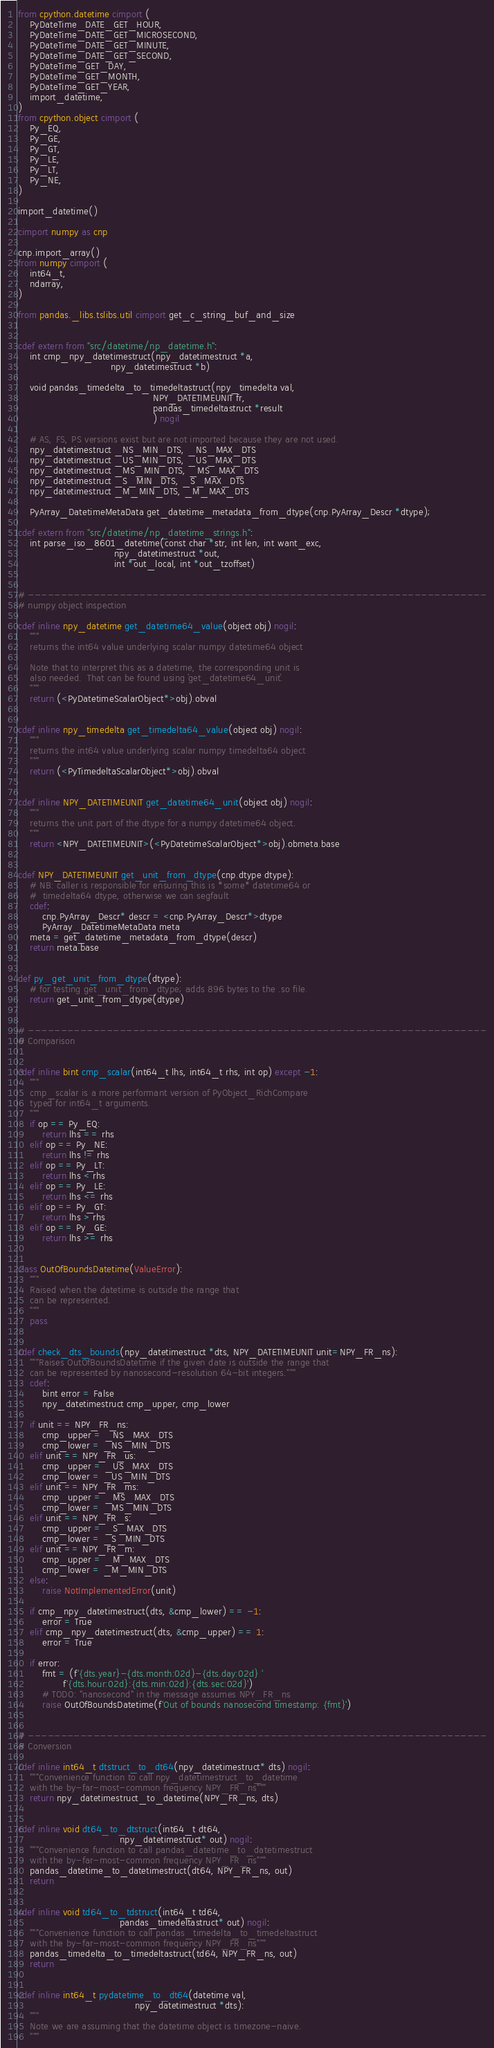Convert code to text. <code><loc_0><loc_0><loc_500><loc_500><_Cython_>from cpython.datetime cimport (
    PyDateTime_DATE_GET_HOUR,
    PyDateTime_DATE_GET_MICROSECOND,
    PyDateTime_DATE_GET_MINUTE,
    PyDateTime_DATE_GET_SECOND,
    PyDateTime_GET_DAY,
    PyDateTime_GET_MONTH,
    PyDateTime_GET_YEAR,
    import_datetime,
)
from cpython.object cimport (
    Py_EQ,
    Py_GE,
    Py_GT,
    Py_LE,
    Py_LT,
    Py_NE,
)

import_datetime()

cimport numpy as cnp

cnp.import_array()
from numpy cimport (
    int64_t,
    ndarray,
)

from pandas._libs.tslibs.util cimport get_c_string_buf_and_size


cdef extern from "src/datetime/np_datetime.h":
    int cmp_npy_datetimestruct(npy_datetimestruct *a,
                               npy_datetimestruct *b)

    void pandas_timedelta_to_timedeltastruct(npy_timedelta val,
                                             NPY_DATETIMEUNIT fr,
                                             pandas_timedeltastruct *result
                                             ) nogil

    # AS, FS, PS versions exist but are not imported because they are not used.
    npy_datetimestruct _NS_MIN_DTS, _NS_MAX_DTS
    npy_datetimestruct _US_MIN_DTS, _US_MAX_DTS
    npy_datetimestruct _MS_MIN_DTS, _MS_MAX_DTS
    npy_datetimestruct _S_MIN_DTS, _S_MAX_DTS
    npy_datetimestruct _M_MIN_DTS, _M_MAX_DTS

    PyArray_DatetimeMetaData get_datetime_metadata_from_dtype(cnp.PyArray_Descr *dtype);

cdef extern from "src/datetime/np_datetime_strings.h":
    int parse_iso_8601_datetime(const char *str, int len, int want_exc,
                                npy_datetimestruct *out,
                                int *out_local, int *out_tzoffset)


# ----------------------------------------------------------------------
# numpy object inspection

cdef inline npy_datetime get_datetime64_value(object obj) nogil:
    """
    returns the int64 value underlying scalar numpy datetime64 object

    Note that to interpret this as a datetime, the corresponding unit is
    also needed.  That can be found using `get_datetime64_unit`.
    """
    return (<PyDatetimeScalarObject*>obj).obval


cdef inline npy_timedelta get_timedelta64_value(object obj) nogil:
    """
    returns the int64 value underlying scalar numpy timedelta64 object
    """
    return (<PyTimedeltaScalarObject*>obj).obval


cdef inline NPY_DATETIMEUNIT get_datetime64_unit(object obj) nogil:
    """
    returns the unit part of the dtype for a numpy datetime64 object.
    """
    return <NPY_DATETIMEUNIT>(<PyDatetimeScalarObject*>obj).obmeta.base


cdef NPY_DATETIMEUNIT get_unit_from_dtype(cnp.dtype dtype):
    # NB: caller is responsible for ensuring this is *some* datetime64 or
    #  timedelta64 dtype, otherwise we can segfault
    cdef:
        cnp.PyArray_Descr* descr = <cnp.PyArray_Descr*>dtype
        PyArray_DatetimeMetaData meta
    meta = get_datetime_metadata_from_dtype(descr)
    return meta.base


def py_get_unit_from_dtype(dtype):
    # for testing get_unit_from_dtype; adds 896 bytes to the .so file.
    return get_unit_from_dtype(dtype)


# ----------------------------------------------------------------------
# Comparison


cdef inline bint cmp_scalar(int64_t lhs, int64_t rhs, int op) except -1:
    """
    cmp_scalar is a more performant version of PyObject_RichCompare
    typed for int64_t arguments.
    """
    if op == Py_EQ:
        return lhs == rhs
    elif op == Py_NE:
        return lhs != rhs
    elif op == Py_LT:
        return lhs < rhs
    elif op == Py_LE:
        return lhs <= rhs
    elif op == Py_GT:
        return lhs > rhs
    elif op == Py_GE:
        return lhs >= rhs


class OutOfBoundsDatetime(ValueError):
    """
    Raised when the datetime is outside the range that
    can be represented.
    """
    pass


cdef check_dts_bounds(npy_datetimestruct *dts, NPY_DATETIMEUNIT unit=NPY_FR_ns):
    """Raises OutOfBoundsDatetime if the given date is outside the range that
    can be represented by nanosecond-resolution 64-bit integers."""
    cdef:
        bint error = False
        npy_datetimestruct cmp_upper, cmp_lower

    if unit == NPY_FR_ns:
        cmp_upper = _NS_MAX_DTS
        cmp_lower = _NS_MIN_DTS
    elif unit == NPY_FR_us:
        cmp_upper = _US_MAX_DTS
        cmp_lower = _US_MIN_DTS
    elif unit == NPY_FR_ms:
        cmp_upper = _MS_MAX_DTS
        cmp_lower = _MS_MIN_DTS
    elif unit == NPY_FR_s:
        cmp_upper = _S_MAX_DTS
        cmp_lower = _S_MIN_DTS
    elif unit == NPY_FR_m:
        cmp_upper = _M_MAX_DTS
        cmp_lower = _M_MIN_DTS
    else:
        raise NotImplementedError(unit)

    if cmp_npy_datetimestruct(dts, &cmp_lower) == -1:
        error = True
    elif cmp_npy_datetimestruct(dts, &cmp_upper) == 1:
        error = True

    if error:
        fmt = (f'{dts.year}-{dts.month:02d}-{dts.day:02d} '
               f'{dts.hour:02d}:{dts.min:02d}:{dts.sec:02d}')
        # TODO: "nanosecond" in the message assumes NPY_FR_ns
        raise OutOfBoundsDatetime(f'Out of bounds nanosecond timestamp: {fmt}')


# ----------------------------------------------------------------------
# Conversion

cdef inline int64_t dtstruct_to_dt64(npy_datetimestruct* dts) nogil:
    """Convenience function to call npy_datetimestruct_to_datetime
    with the by-far-most-common frequency NPY_FR_ns"""
    return npy_datetimestruct_to_datetime(NPY_FR_ns, dts)


cdef inline void dt64_to_dtstruct(int64_t dt64,
                                  npy_datetimestruct* out) nogil:
    """Convenience function to call pandas_datetime_to_datetimestruct
    with the by-far-most-common frequency NPY_FR_ns"""
    pandas_datetime_to_datetimestruct(dt64, NPY_FR_ns, out)
    return


cdef inline void td64_to_tdstruct(int64_t td64,
                                  pandas_timedeltastruct* out) nogil:
    """Convenience function to call pandas_timedelta_to_timedeltastruct
    with the by-far-most-common frequency NPY_FR_ns"""
    pandas_timedelta_to_timedeltastruct(td64, NPY_FR_ns, out)
    return


cdef inline int64_t pydatetime_to_dt64(datetime val,
                                       npy_datetimestruct *dts):
    """
    Note we are assuming that the datetime object is timezone-naive.
    """</code> 